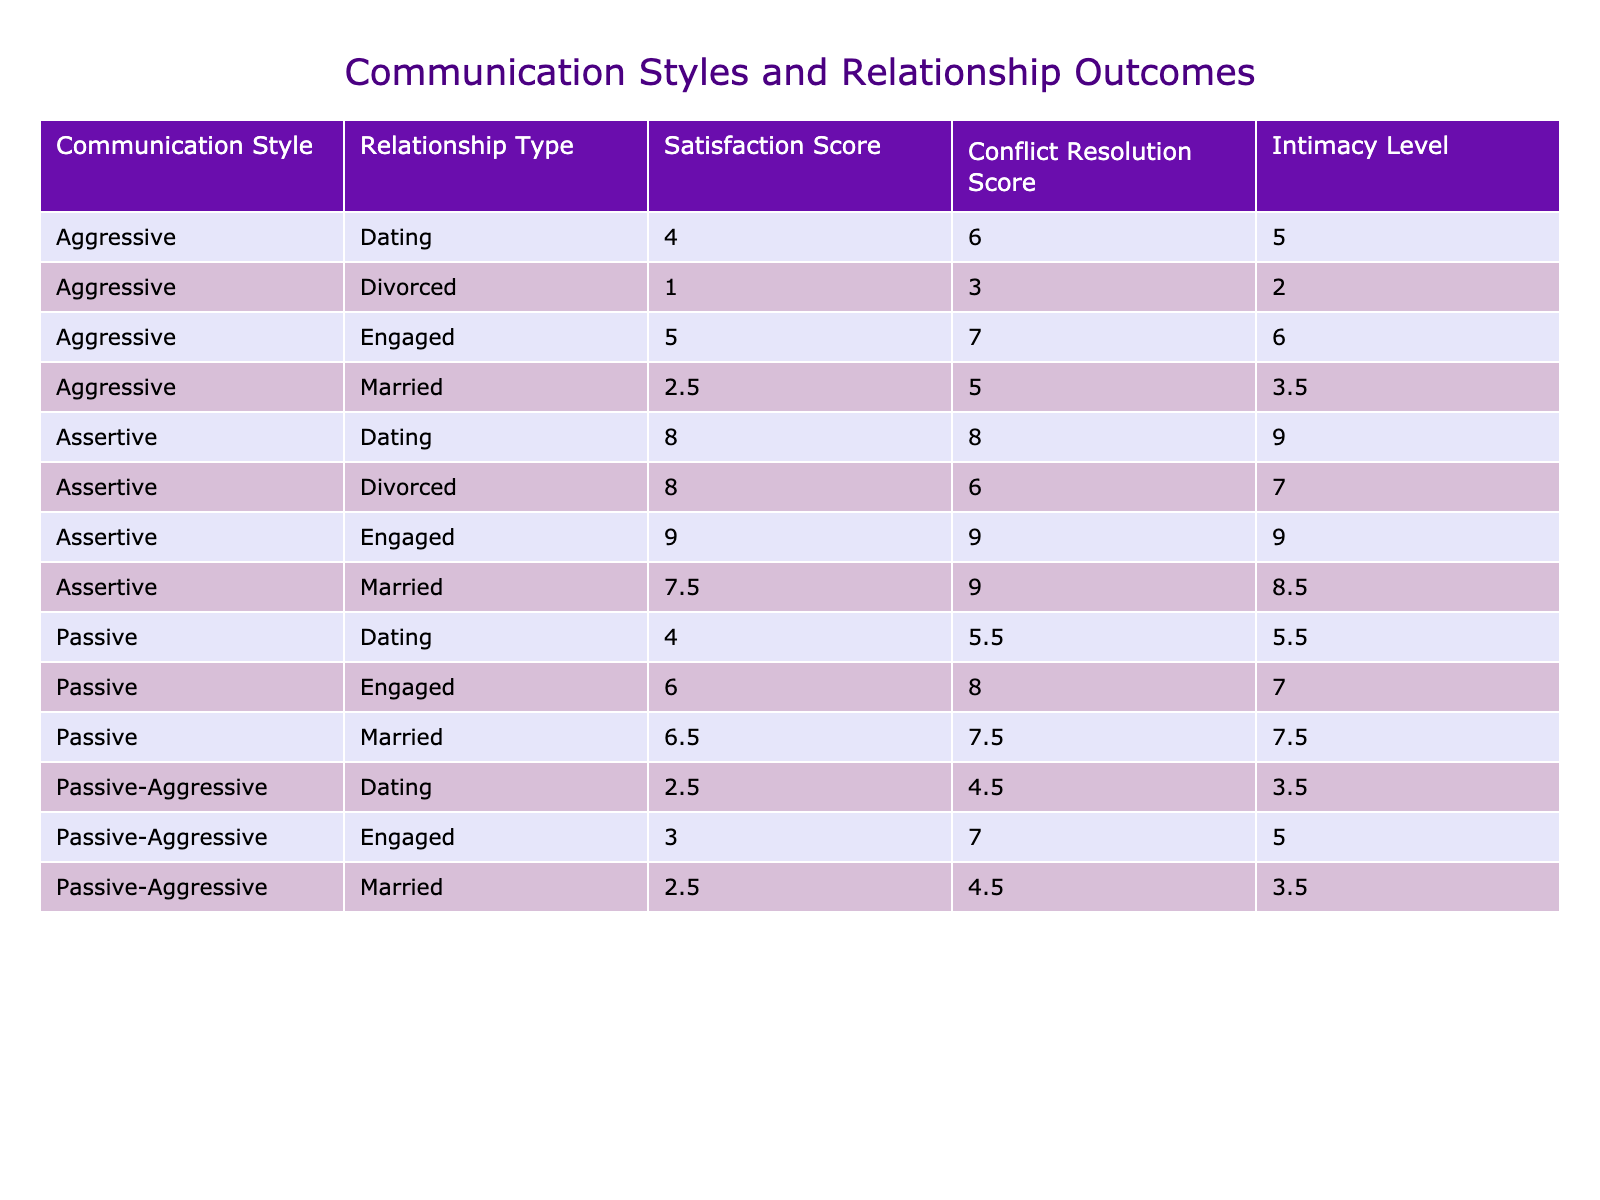What is the satisfaction score for the Assertive communication style in married relationships? The table shows that the satisfaction score for the Assertive style in married relationships is 8.
Answer: 8 Which relationship type has the highest average Intimacy Level? To find this, I looked at the average Intimacy Level for each relationship type: Married (7.33), Dating (6.50), Engaged (8.00), and Divorced (6.00). The Engaged relationship type has the highest average Intimacy Level of 8.
Answer: 8.00 Is there a relationship type where the Aggressive communication style has a positive Satisfaction Score? Yes, there are instances in the table where the Aggressive communication style is present, but the only positive satisfaction score is found in the Engaged relationship type with a score of 6.
Answer: Yes What is the average Conflict Resolution Score across all communication styles for the 'Dating' relationship type? I focused on the Dating relationship type and found the Conflict Resolution Scores: 4 (Passive), 8 (Assertive), 4 (Aggressive), and 3 (Passive-Aggressive). Summing these gives 4 + 8 + 4 + 3 = 19, and there are 4 scores, so the average is 19 divided by 4, which equals 4.75.
Answer: 4.75 Which communication style has the lowest average Satisfaction Score, and what is that score? I calculated the average Satisfaction Score for each communication style: Assertive (8.57), Passive (6.67), Aggressive (3.75), and Passive-Aggressive (3.67). The Passive-Aggressive style has the lowest average Satisfaction Score of 3.67.
Answer: Passive-Aggressive, 3.67 Does the Passive communication style ever have a higher Satisfaction Score than the Assertive style across all relationship types? No, by examining the Satisfaction Scores, the Passive communication style has a maximum score of 8, while Assertive has maximum scored 9; thus, Passive never surpasses Assertive in any relationship type.
Answer: No What is the total Intimacy Level score for all married relationships? To find this, I added the Intimacy Levels for all married relationships: 9 (Assertive) + 7 (Passive) + 6 (Aggressive) + 5 (Passive-Aggressive) + 9 (Assertive) = 36. So the total Intimacy Level score for married relationships is 36.
Answer: 36 What percentage of communication styles in engaged relationships have a Satisfaction Score above 6? There are three engaged relationships in the table, with Satisfaction Scores of 5 (Passive-Aggressive), 9 (Assertive), and 6 (Aggressive). Out of these, only two scores (Assertive and Aggressive) are above 6. Therefore, the percentage is (2/3) * 100 = 66.67%.
Answer: 66.67% 